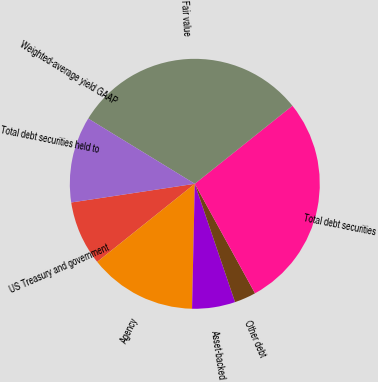Convert chart. <chart><loc_0><loc_0><loc_500><loc_500><pie_chart><fcel>US Treasury and government<fcel>Agency<fcel>Asset-backed<fcel>Other debt<fcel>Total debt securities<fcel>Fair value<fcel>Weighted-average yield GAAP<fcel>Total debt securities held to<nl><fcel>8.35%<fcel>13.91%<fcel>5.57%<fcel>2.78%<fcel>27.73%<fcel>30.52%<fcel>0.0%<fcel>11.13%<nl></chart> 